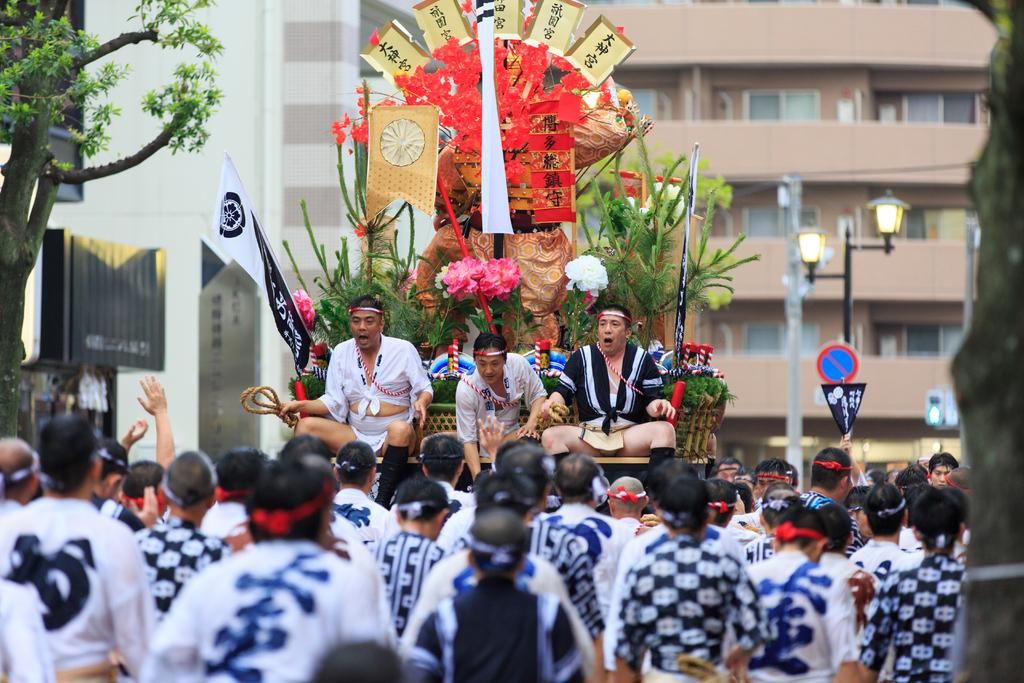What is happening with the people in the image? There are people on a vehicle in the image. What else can be seen with the people on the vehicle? There are flowers present with the people on the vehicle. What are the people standing in front of the vehicle doing? The people standing in front of the vehicle are watching. What can be seen in the background of the image? There are buildings and trees visible behind the vehicle. What type of afterthought is being discussed by the minister in the image? There is no minister or afterthought present in the image. How many masses are being held in the image? There is no mass or religious ceremony depicted in the image. 